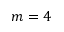Convert formula to latex. <formula><loc_0><loc_0><loc_500><loc_500>m = 4</formula> 